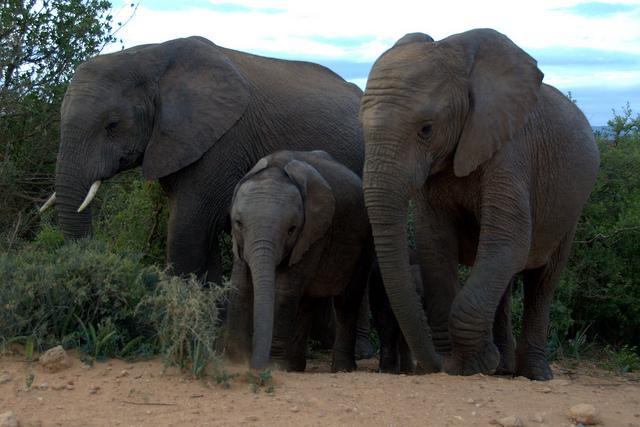What is the baby elephant called?

Choices:
A) calf
B) bullock
C) kit
D) colt calf 